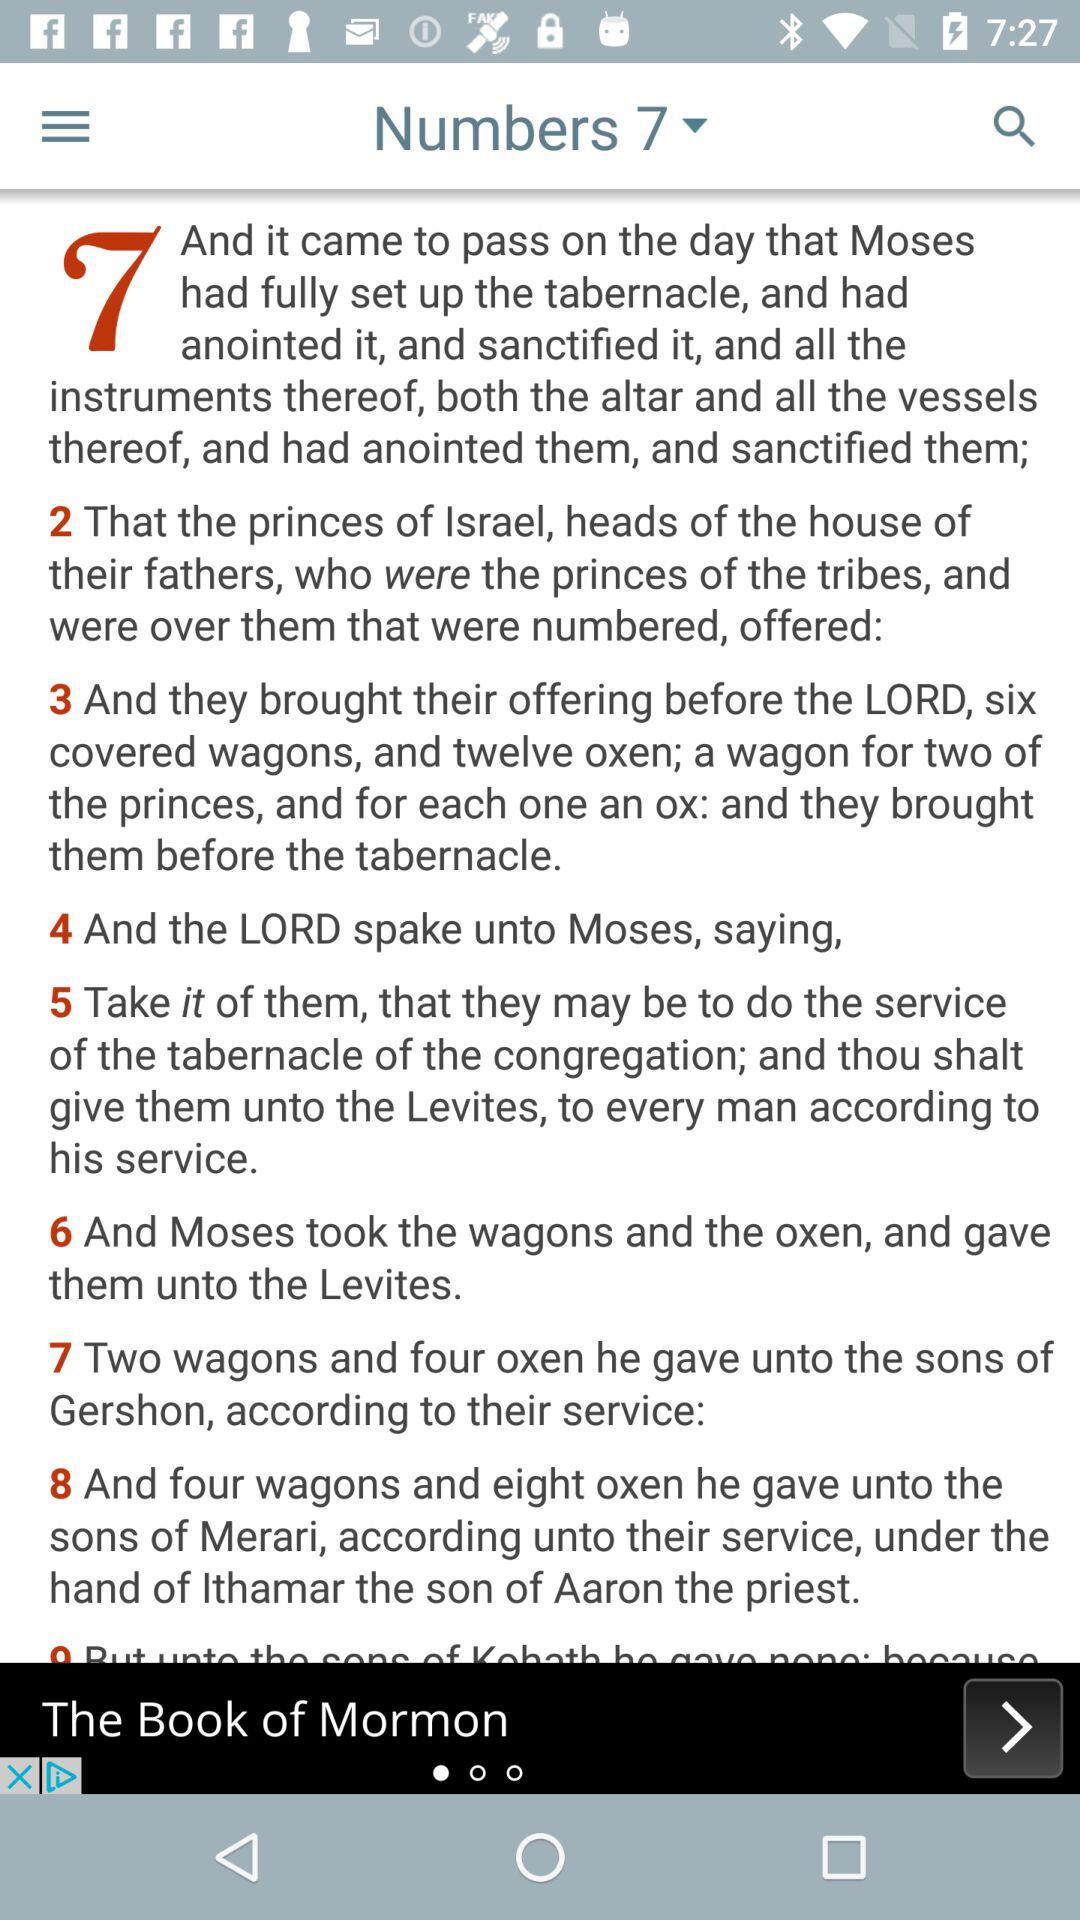How many more wagons were given to the sons of Merari than the sons of Gershon?
Answer the question using a single word or phrase. 2 